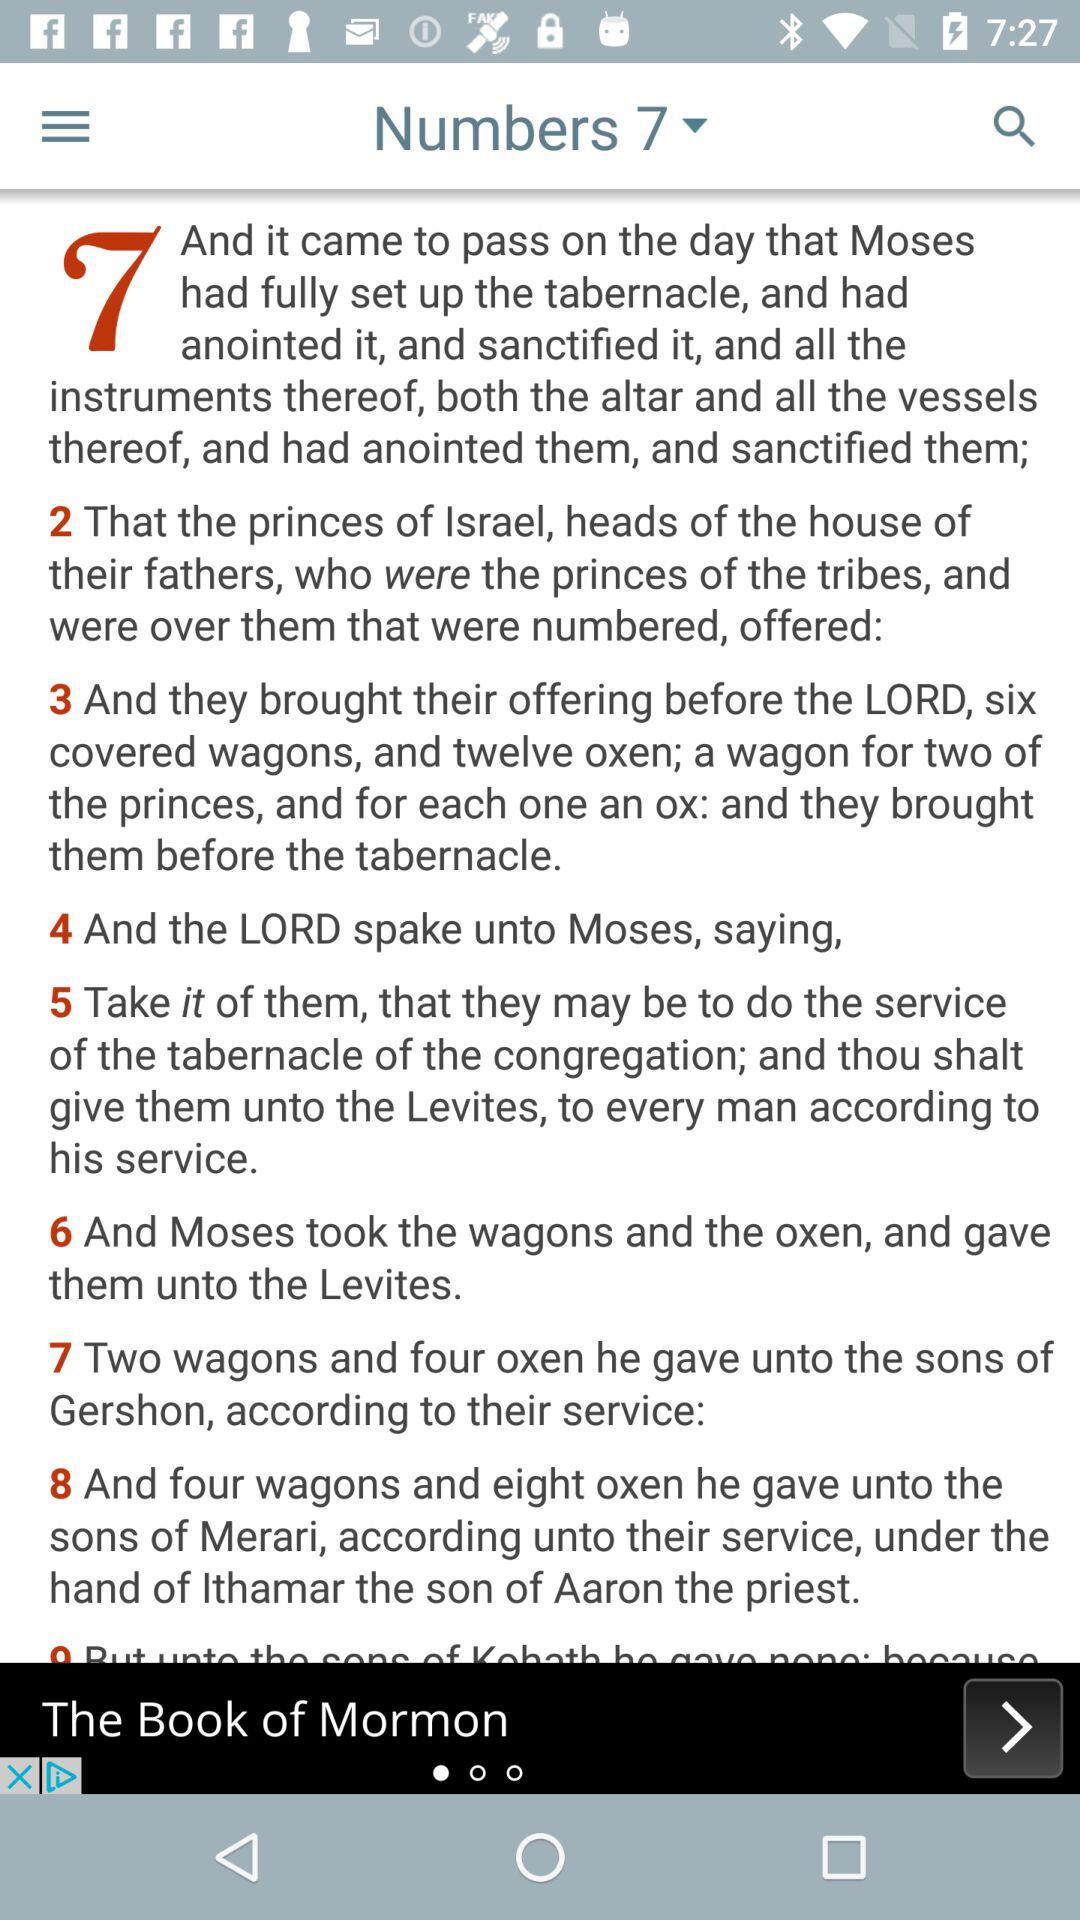How many more wagons were given to the sons of Merari than the sons of Gershon?
Answer the question using a single word or phrase. 2 